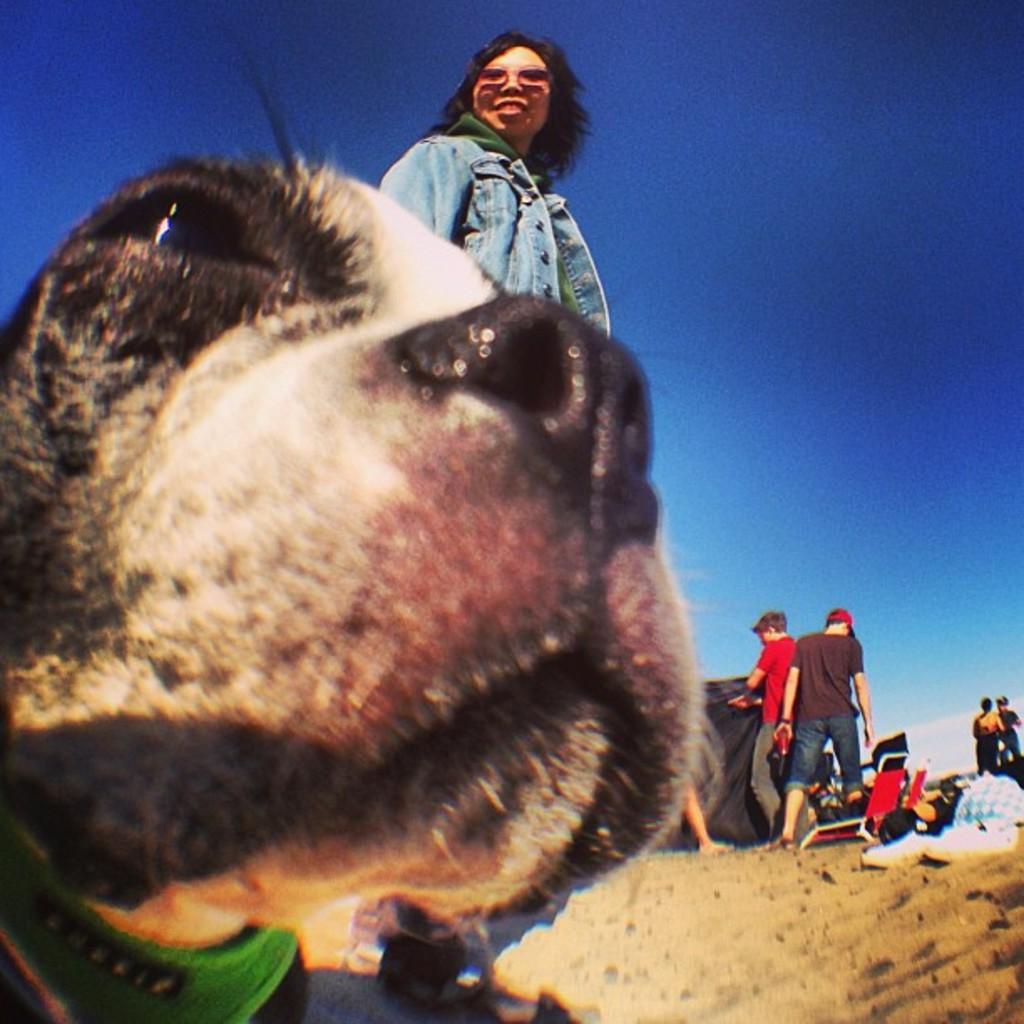How would you summarize this image in a sentence or two? In this image we can see an animal and a few people standing, we can see the sand, there are a few chairs, beside we can see few objects, at the top we can see the sky with clouds. 